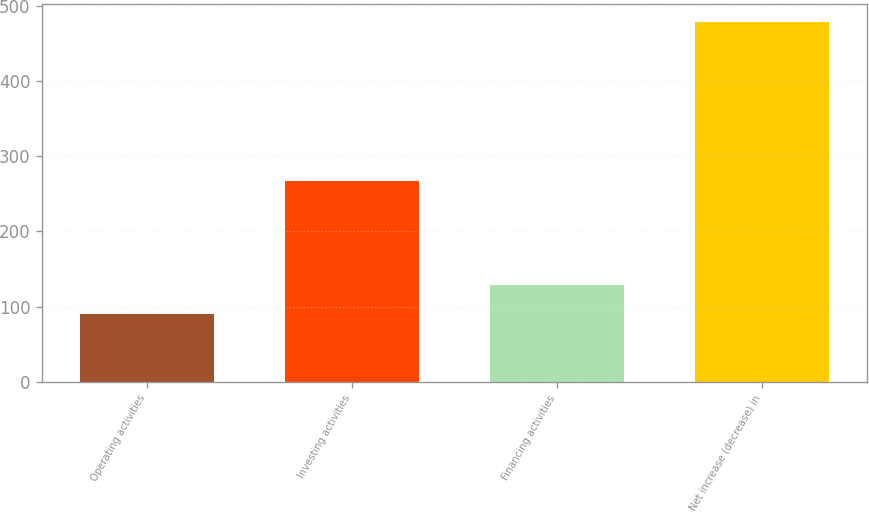Convert chart. <chart><loc_0><loc_0><loc_500><loc_500><bar_chart><fcel>Operating activities<fcel>Investing activities<fcel>Financing activities<fcel>Net increase (decrease) in<nl><fcel>90<fcel>267<fcel>128.9<fcel>479<nl></chart> 